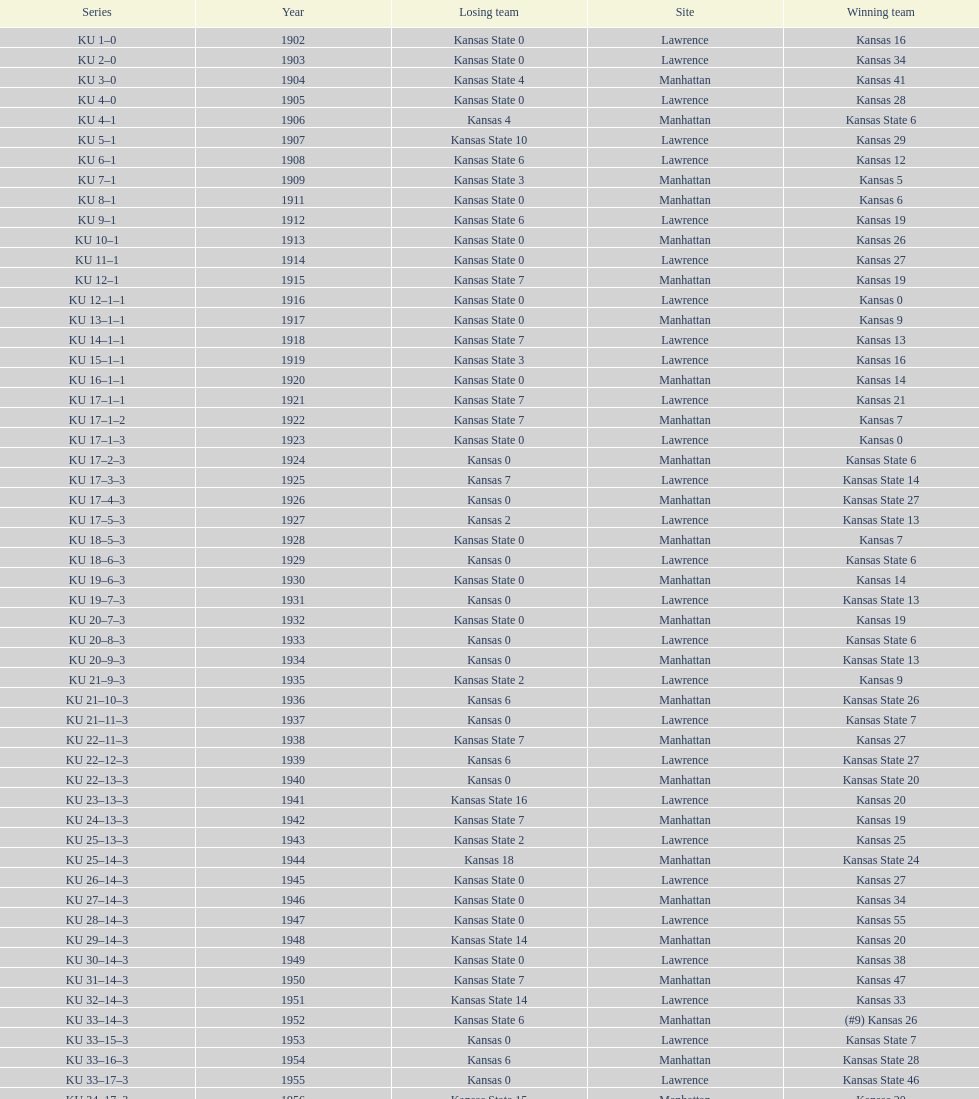How many times did kansas and kansas state play in lawrence from 1902-1968? 34. 